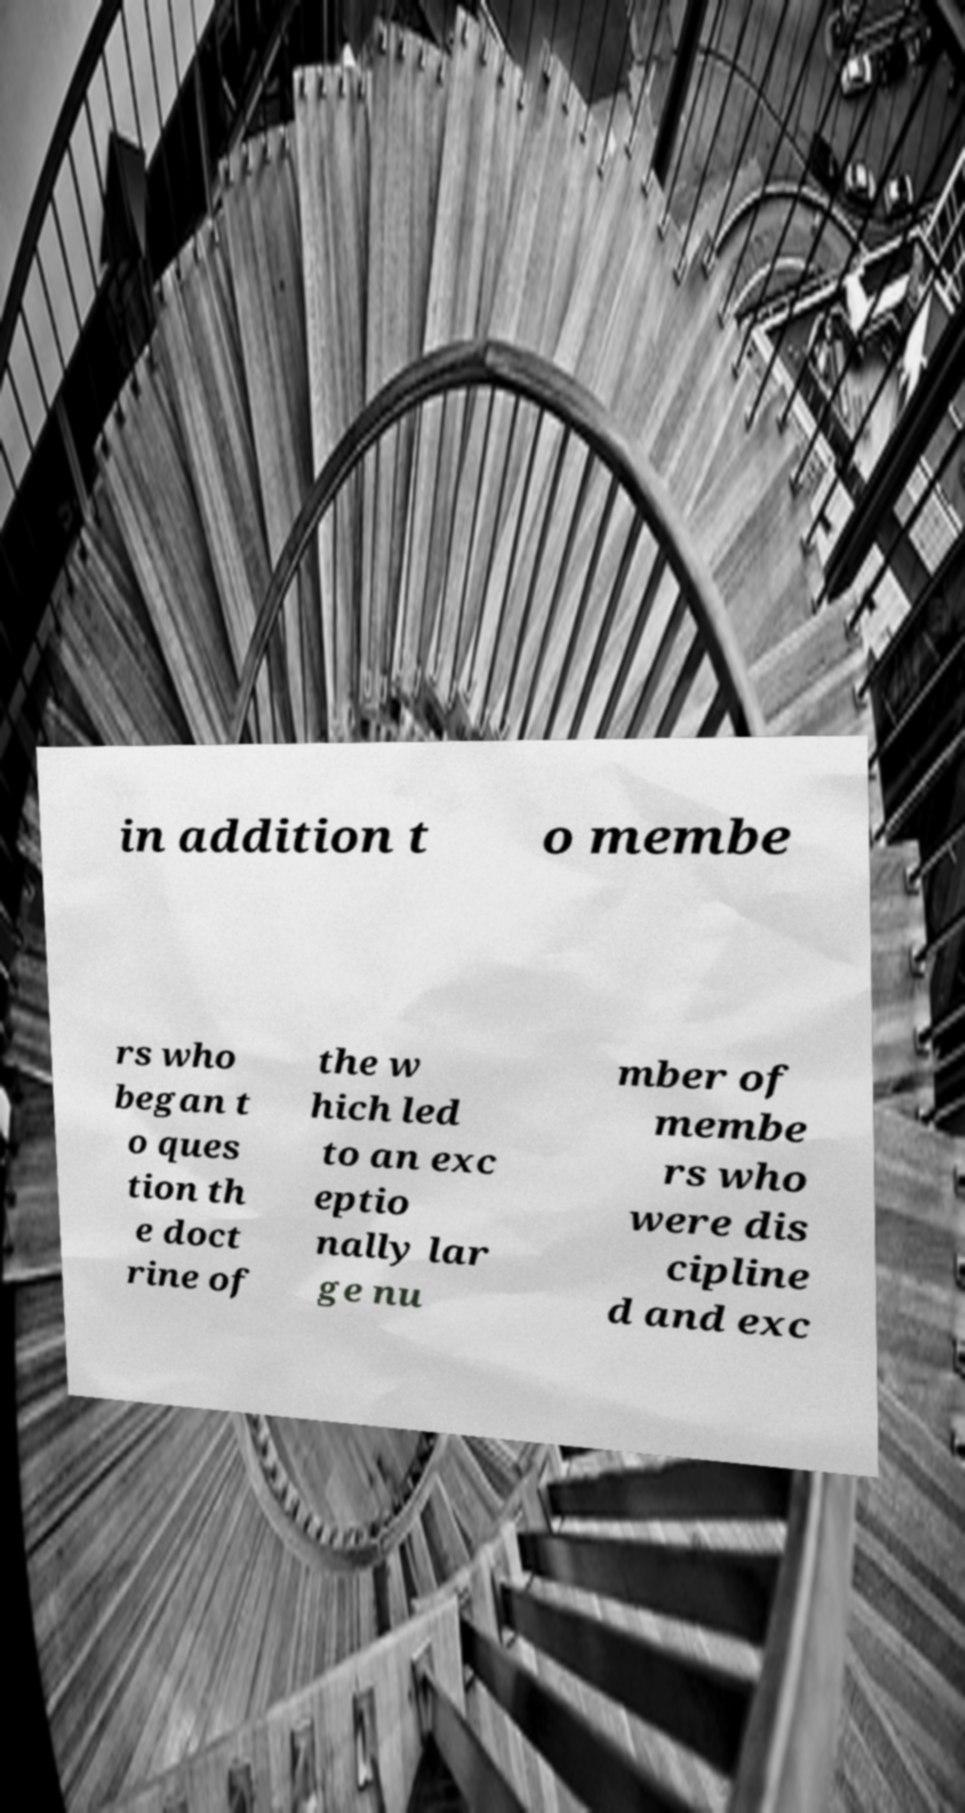Can you accurately transcribe the text from the provided image for me? in addition t o membe rs who began t o ques tion th e doct rine of the w hich led to an exc eptio nally lar ge nu mber of membe rs who were dis cipline d and exc 